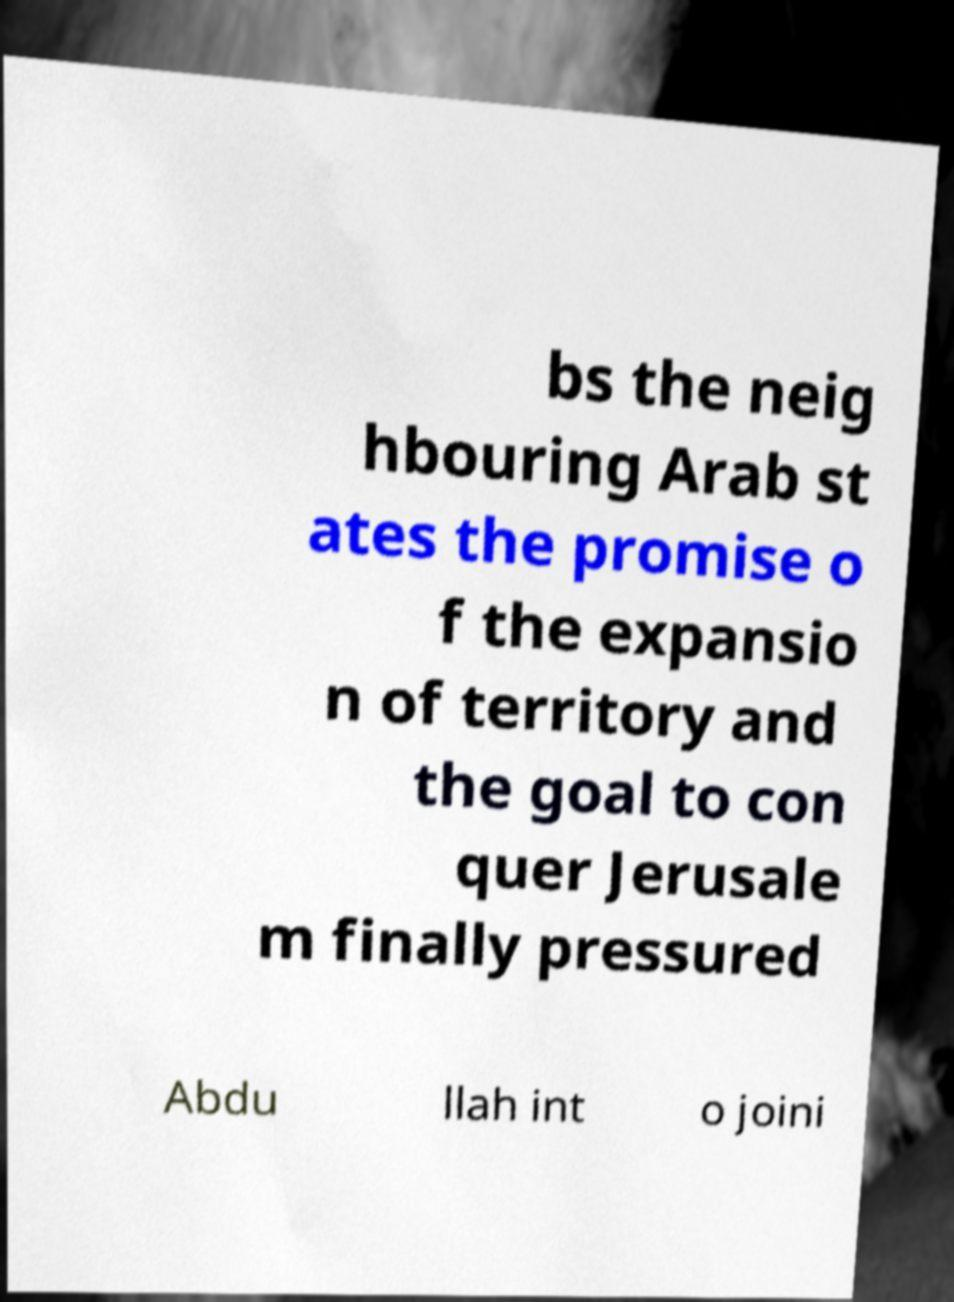There's text embedded in this image that I need extracted. Can you transcribe it verbatim? bs the neig hbouring Arab st ates the promise o f the expansio n of territory and the goal to con quer Jerusale m finally pressured Abdu llah int o joini 